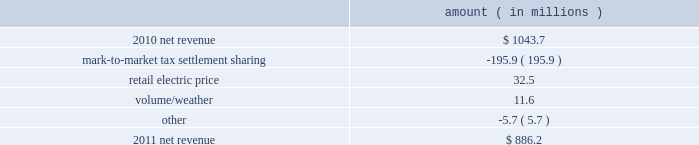Entergy louisiana , llc and subsidiaries management 2019s financial discussion and analysis plan to spin off the utility 2019s transmission business see the 201cplan to spin off the utility 2019s transmission business 201d section of entergy corporation and subsidiaries management 2019s financial discussion and analysis for a discussion of this matter , including the planned retirement of debt and preferred securities .
Results of operations net income 2011 compared to 2010 net income increased $ 242.5 million primarily due to a settlement with the irs related to the mark-to-market income tax treatment of power purchase contracts , which resulted in a $ 422 million income tax benefit .
The net income effect was partially offset by a $ 199 million regulatory charge , which reduced net revenue , because a portion of the benefit will be shared with customers .
See note 3 to the financial statements for additional discussion of the settlement and benefit sharing .
2010 compared to 2009 net income decreased slightly by $ 1.4 million primarily due to higher other operation and maintenance expenses , a higher effective income tax rate , and higher interest expense , almost entirely offset by higher net revenue .
Net revenue 2011 compared to 2010 net revenue consists of operating revenues net of : 1 ) fuel , fuel-related expenses , and gas purchased for resale , 2 ) purchased power expenses , and 3 ) other regulatory charges ( credits ) .
Following is an analysis of the change in net revenue comparing 2011 to 2010 .
Amount ( in millions ) .
The mark-to-market tax settlement sharing variance results from a regulatory charge because a portion of the benefits of a settlement with the irs related to the mark-to-market income tax treatment of power purchase contracts will be shared with customers , slightly offset by the amortization of a portion of that charge beginning in october 2011 .
See notes 3 and 8 to the financial statements for additional discussion of the settlement and benefit sharing .
The retail electric price variance is primarily due to a formula rate plan increase effective may 2011 .
See note 2 to the financial statements for discussion of the formula rate plan increase. .
What is change in percentage points in net income margin in 2011? 
Computations: (242.5 / 886.2)
Answer: 0.27364. 